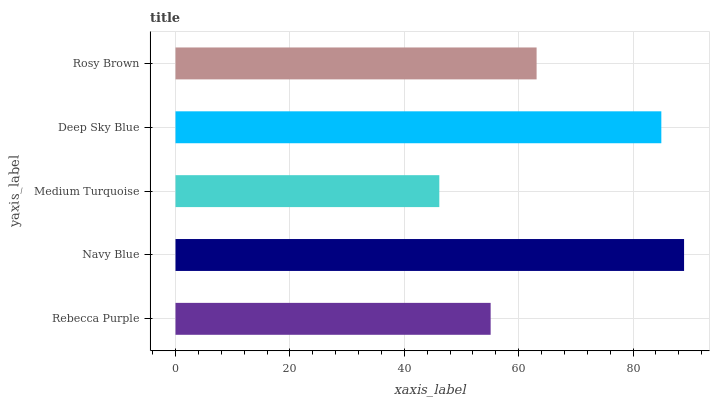Is Medium Turquoise the minimum?
Answer yes or no. Yes. Is Navy Blue the maximum?
Answer yes or no. Yes. Is Navy Blue the minimum?
Answer yes or no. No. Is Medium Turquoise the maximum?
Answer yes or no. No. Is Navy Blue greater than Medium Turquoise?
Answer yes or no. Yes. Is Medium Turquoise less than Navy Blue?
Answer yes or no. Yes. Is Medium Turquoise greater than Navy Blue?
Answer yes or no. No. Is Navy Blue less than Medium Turquoise?
Answer yes or no. No. Is Rosy Brown the high median?
Answer yes or no. Yes. Is Rosy Brown the low median?
Answer yes or no. Yes. Is Medium Turquoise the high median?
Answer yes or no. No. Is Rebecca Purple the low median?
Answer yes or no. No. 